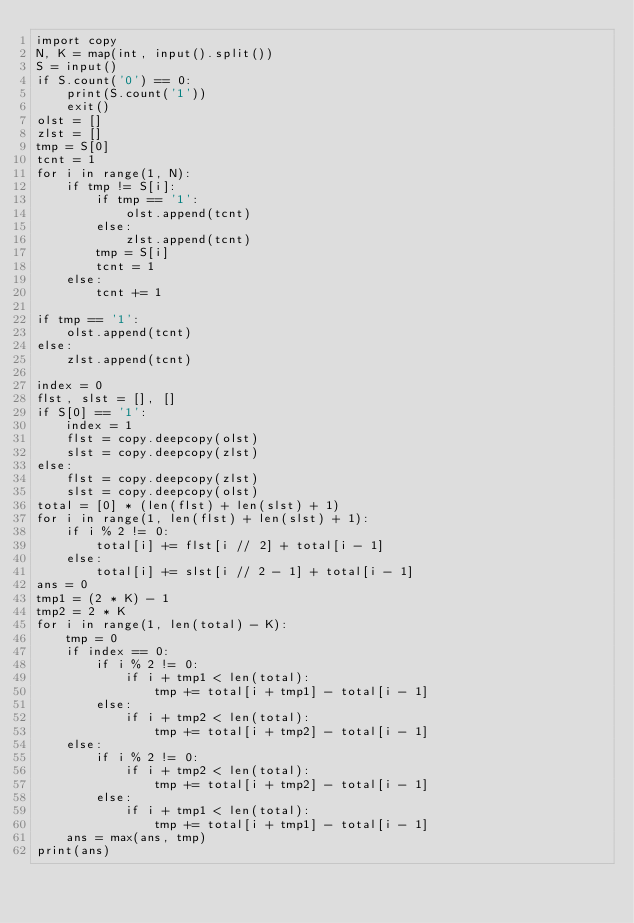<code> <loc_0><loc_0><loc_500><loc_500><_Python_>import copy
N, K = map(int, input().split())
S = input()
if S.count('0') == 0:
    print(S.count('1'))
    exit()
olst = []
zlst = []
tmp = S[0]
tcnt = 1
for i in range(1, N):
    if tmp != S[i]:
        if tmp == '1':
            olst.append(tcnt)
        else:
            zlst.append(tcnt)
        tmp = S[i]
        tcnt = 1
    else:
        tcnt += 1

if tmp == '1':
    olst.append(tcnt)
else:
    zlst.append(tcnt)

index = 0
flst, slst = [], []
if S[0] == '1':
    index = 1
    flst = copy.deepcopy(olst)
    slst = copy.deepcopy(zlst)
else:
    flst = copy.deepcopy(zlst)
    slst = copy.deepcopy(olst)
total = [0] * (len(flst) + len(slst) + 1)
for i in range(1, len(flst) + len(slst) + 1):
    if i % 2 != 0:
        total[i] += flst[i // 2] + total[i - 1]
    else:
        total[i] += slst[i // 2 - 1] + total[i - 1]
ans = 0
tmp1 = (2 * K) - 1
tmp2 = 2 * K
for i in range(1, len(total) - K):
    tmp = 0
    if index == 0:
        if i % 2 != 0:
            if i + tmp1 < len(total):
                tmp += total[i + tmp1] - total[i - 1]
        else:
            if i + tmp2 < len(total):
                tmp += total[i + tmp2] - total[i - 1]
    else:
        if i % 2 != 0:
            if i + tmp2 < len(total):
                tmp += total[i + tmp2] - total[i - 1]
        else:
            if i + tmp1 < len(total):
                tmp += total[i + tmp1] - total[i - 1]
    ans = max(ans, tmp)
print(ans)</code> 